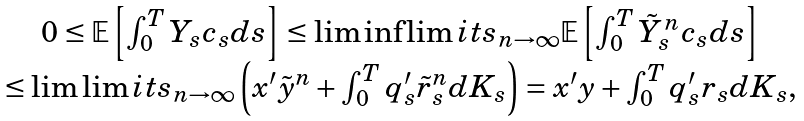Convert formula to latex. <formula><loc_0><loc_0><loc_500><loc_500>\begin{array} { c } 0 \leq \mathbb { E } \left [ \int _ { 0 } ^ { T } Y _ { s } c _ { s } d s \right ] \leq \liminf \lim i t s _ { n \to \infty } \mathbb { E } \left [ \int _ { 0 } ^ { T } \tilde { Y } ^ { n } _ { s } c _ { s } d s \right ] \\ \leq \lim \lim i t s _ { n \to \infty } \left ( x ^ { \prime } \tilde { y } ^ { n } + \int _ { 0 } ^ { T } q ^ { \prime } _ { s } \tilde { r } ^ { n } _ { s } d K _ { s } \right ) = x ^ { \prime } y + \int _ { 0 } ^ { T } q ^ { \prime } _ { s } r _ { s } d K _ { s } , \\ \end{array}</formula> 